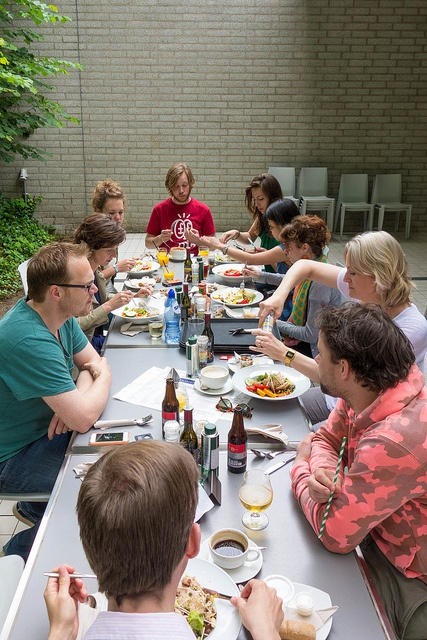Describe the objects in this image and their specific colors. I can see dining table in darkgreen, lightgray, darkgray, gray, and black tones, people in darkgreen, brown, black, salmon, and maroon tones, people in darkgreen, black, lavender, and gray tones, people in darkgreen, black, teal, and gray tones, and people in darkgreen, gray, lightgray, darkgray, and tan tones in this image. 